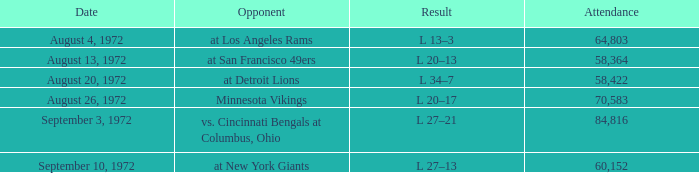Would you be able to parse every entry in this table? {'header': ['Date', 'Opponent', 'Result', 'Attendance'], 'rows': [['August 4, 1972', 'at Los Angeles Rams', 'L 13–3', '64,803'], ['August 13, 1972', 'at San Francisco 49ers', 'L 20–13', '58,364'], ['August 20, 1972', 'at Detroit Lions', 'L 34–7', '58,422'], ['August 26, 1972', 'Minnesota Vikings', 'L 20–17', '70,583'], ['September 3, 1972', 'vs. Cincinnati Bengals at Columbus, Ohio', 'L 27–21', '84,816'], ['September 10, 1972', 'at New York Giants', 'L 27–13', '60,152']]} How many weeks had an attendance larger than 84,816? 0.0. 